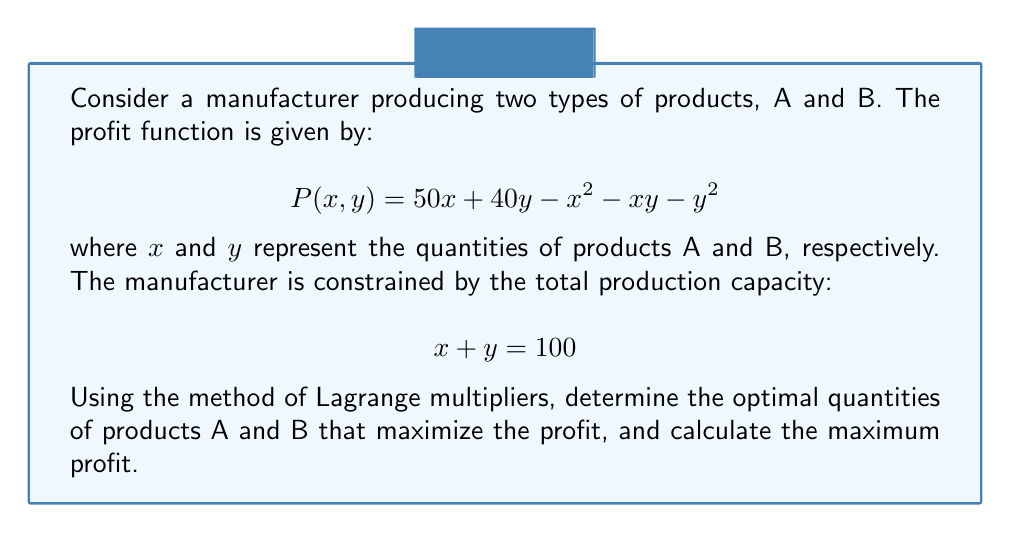Can you answer this question? To solve this optimization problem using Lagrange multipliers, we follow these steps:

1) First, we form the Lagrangian function:
   $$L(x,y,\lambda) = 50x + 40y - x^2 - xy - y^2 + \lambda(100 - x - y)$$

2) Now, we take partial derivatives with respect to x, y, and λ:
   $$\frac{\partial L}{\partial x} = 50 - 2x - y - \lambda = 0$$
   $$\frac{\partial L}{\partial y} = 40 - x - 2y - \lambda = 0$$
   $$\frac{\partial L}{\partial \lambda} = 100 - x - y = 0$$

3) From the third equation, we already know that $x + y = 100$.

4) Subtracting the second equation from the first:
   $$(50 - 2x - y - \lambda) - (40 - x - 2y - \lambda) = 0$$
   $$10 - x + y = 0$$
   $$x = y + 10$$

5) Substituting this into $x + y = 100$:
   $$(y + 10) + y = 100$$
   $$2y = 90$$
   $$y = 45$$

6) Therefore, $x = 55$.

7) To find the maximum profit, we substitute these values back into the original profit function:
   $$P(55,45) = 50(55) + 40(45) - 55^2 - 55(45) - 45^2$$
   $$= 2750 + 1800 - 3025 - 2475 - 2025$$
   $$= -2975$$
Answer: $x = 55$, $y = 45$, Maximum profit = $-2975$ 